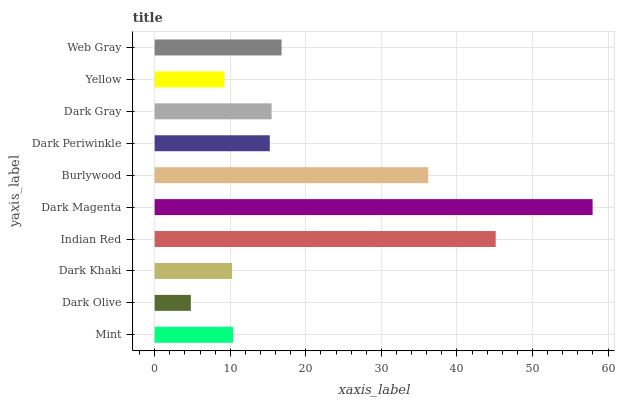Is Dark Olive the minimum?
Answer yes or no. Yes. Is Dark Magenta the maximum?
Answer yes or no. Yes. Is Dark Khaki the minimum?
Answer yes or no. No. Is Dark Khaki the maximum?
Answer yes or no. No. Is Dark Khaki greater than Dark Olive?
Answer yes or no. Yes. Is Dark Olive less than Dark Khaki?
Answer yes or no. Yes. Is Dark Olive greater than Dark Khaki?
Answer yes or no. No. Is Dark Khaki less than Dark Olive?
Answer yes or no. No. Is Dark Gray the high median?
Answer yes or no. Yes. Is Dark Periwinkle the low median?
Answer yes or no. Yes. Is Mint the high median?
Answer yes or no. No. Is Mint the low median?
Answer yes or no. No. 